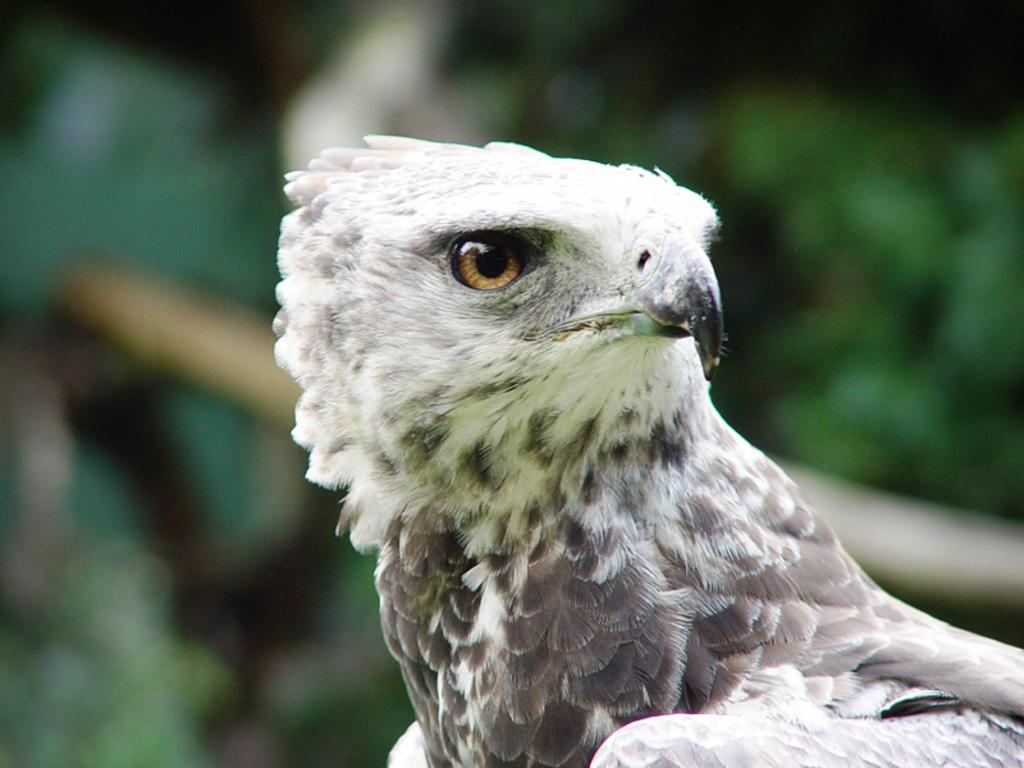What type of animal can be seen in the image? There is a bird in the image. Can you describe the background of the image? The background of the image is blurry. What type of board is the bird standing on in the image? There is no board present in the image; the bird is not standing on any surface. 